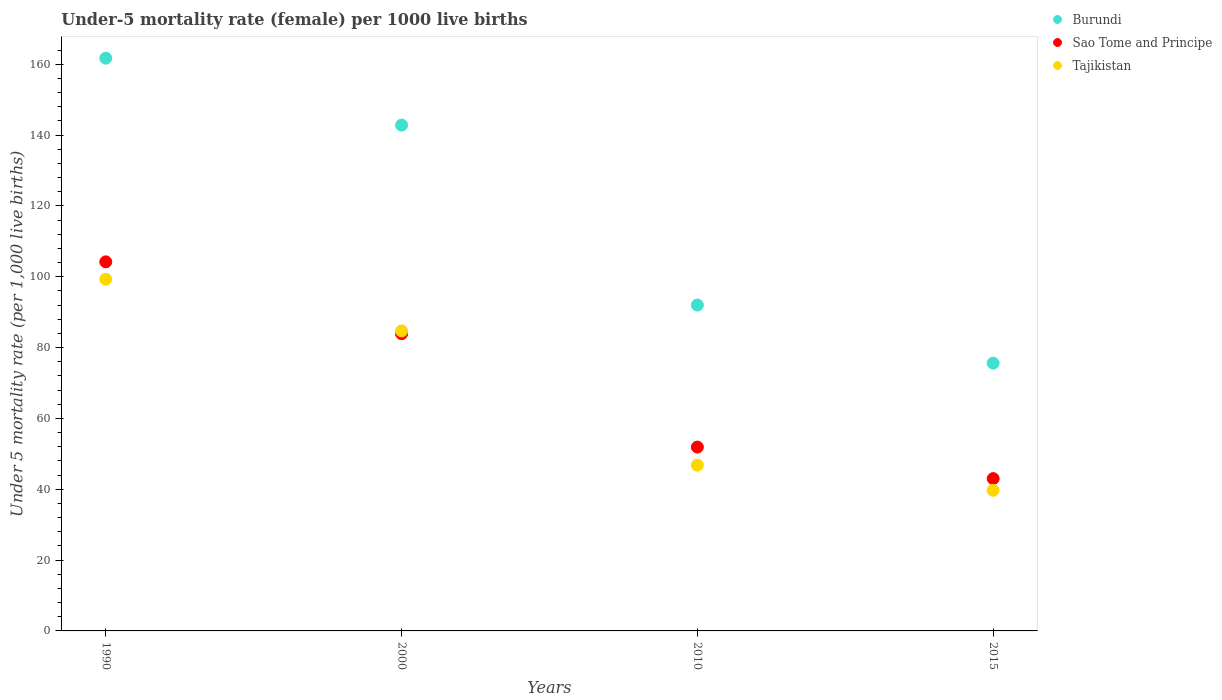How many different coloured dotlines are there?
Your response must be concise. 3. Is the number of dotlines equal to the number of legend labels?
Your answer should be very brief. Yes. What is the under-five mortality rate in Sao Tome and Principe in 1990?
Offer a very short reply. 104.2. Across all years, what is the maximum under-five mortality rate in Burundi?
Make the answer very short. 161.7. Across all years, what is the minimum under-five mortality rate in Tajikistan?
Your answer should be compact. 39.7. In which year was the under-five mortality rate in Burundi minimum?
Keep it short and to the point. 2015. What is the total under-five mortality rate in Burundi in the graph?
Ensure brevity in your answer.  472.1. What is the difference between the under-five mortality rate in Sao Tome and Principe in 2010 and that in 2015?
Provide a succinct answer. 8.9. What is the difference between the under-five mortality rate in Tajikistan in 1990 and the under-five mortality rate in Sao Tome and Principe in 2000?
Give a very brief answer. 15.4. What is the average under-five mortality rate in Tajikistan per year?
Offer a very short reply. 67.62. In the year 1990, what is the difference between the under-five mortality rate in Sao Tome and Principe and under-five mortality rate in Burundi?
Your answer should be compact. -57.5. In how many years, is the under-five mortality rate in Tajikistan greater than 68?
Your response must be concise. 2. What is the ratio of the under-five mortality rate in Tajikistan in 1990 to that in 2000?
Your response must be concise. 1.17. Is the difference between the under-five mortality rate in Sao Tome and Principe in 1990 and 2010 greater than the difference between the under-five mortality rate in Burundi in 1990 and 2010?
Make the answer very short. No. What is the difference between the highest and the second highest under-five mortality rate in Tajikistan?
Offer a very short reply. 14.6. What is the difference between the highest and the lowest under-five mortality rate in Sao Tome and Principe?
Ensure brevity in your answer.  61.2. Is it the case that in every year, the sum of the under-five mortality rate in Tajikistan and under-five mortality rate in Sao Tome and Principe  is greater than the under-five mortality rate in Burundi?
Make the answer very short. Yes. Is the under-five mortality rate in Burundi strictly greater than the under-five mortality rate in Sao Tome and Principe over the years?
Your answer should be compact. Yes. What is the difference between two consecutive major ticks on the Y-axis?
Keep it short and to the point. 20. Are the values on the major ticks of Y-axis written in scientific E-notation?
Your response must be concise. No. Does the graph contain grids?
Provide a succinct answer. No. What is the title of the graph?
Your answer should be compact. Under-5 mortality rate (female) per 1000 live births. Does "Iraq" appear as one of the legend labels in the graph?
Make the answer very short. No. What is the label or title of the X-axis?
Give a very brief answer. Years. What is the label or title of the Y-axis?
Your answer should be very brief. Under 5 mortality rate (per 1,0 live births). What is the Under 5 mortality rate (per 1,000 live births) of Burundi in 1990?
Provide a short and direct response. 161.7. What is the Under 5 mortality rate (per 1,000 live births) in Sao Tome and Principe in 1990?
Make the answer very short. 104.2. What is the Under 5 mortality rate (per 1,000 live births) of Tajikistan in 1990?
Offer a very short reply. 99.3. What is the Under 5 mortality rate (per 1,000 live births) in Burundi in 2000?
Provide a succinct answer. 142.8. What is the Under 5 mortality rate (per 1,000 live births) in Sao Tome and Principe in 2000?
Offer a terse response. 83.9. What is the Under 5 mortality rate (per 1,000 live births) in Tajikistan in 2000?
Keep it short and to the point. 84.7. What is the Under 5 mortality rate (per 1,000 live births) of Burundi in 2010?
Keep it short and to the point. 92. What is the Under 5 mortality rate (per 1,000 live births) in Sao Tome and Principe in 2010?
Offer a very short reply. 51.9. What is the Under 5 mortality rate (per 1,000 live births) of Tajikistan in 2010?
Your answer should be compact. 46.8. What is the Under 5 mortality rate (per 1,000 live births) of Burundi in 2015?
Give a very brief answer. 75.6. What is the Under 5 mortality rate (per 1,000 live births) of Tajikistan in 2015?
Make the answer very short. 39.7. Across all years, what is the maximum Under 5 mortality rate (per 1,000 live births) in Burundi?
Offer a terse response. 161.7. Across all years, what is the maximum Under 5 mortality rate (per 1,000 live births) of Sao Tome and Principe?
Give a very brief answer. 104.2. Across all years, what is the maximum Under 5 mortality rate (per 1,000 live births) in Tajikistan?
Give a very brief answer. 99.3. Across all years, what is the minimum Under 5 mortality rate (per 1,000 live births) in Burundi?
Provide a succinct answer. 75.6. Across all years, what is the minimum Under 5 mortality rate (per 1,000 live births) of Sao Tome and Principe?
Ensure brevity in your answer.  43. Across all years, what is the minimum Under 5 mortality rate (per 1,000 live births) in Tajikistan?
Ensure brevity in your answer.  39.7. What is the total Under 5 mortality rate (per 1,000 live births) of Burundi in the graph?
Your response must be concise. 472.1. What is the total Under 5 mortality rate (per 1,000 live births) of Sao Tome and Principe in the graph?
Give a very brief answer. 283. What is the total Under 5 mortality rate (per 1,000 live births) in Tajikistan in the graph?
Your response must be concise. 270.5. What is the difference between the Under 5 mortality rate (per 1,000 live births) of Burundi in 1990 and that in 2000?
Your response must be concise. 18.9. What is the difference between the Under 5 mortality rate (per 1,000 live births) of Sao Tome and Principe in 1990 and that in 2000?
Make the answer very short. 20.3. What is the difference between the Under 5 mortality rate (per 1,000 live births) in Tajikistan in 1990 and that in 2000?
Your response must be concise. 14.6. What is the difference between the Under 5 mortality rate (per 1,000 live births) of Burundi in 1990 and that in 2010?
Your answer should be very brief. 69.7. What is the difference between the Under 5 mortality rate (per 1,000 live births) of Sao Tome and Principe in 1990 and that in 2010?
Your answer should be compact. 52.3. What is the difference between the Under 5 mortality rate (per 1,000 live births) of Tajikistan in 1990 and that in 2010?
Give a very brief answer. 52.5. What is the difference between the Under 5 mortality rate (per 1,000 live births) of Burundi in 1990 and that in 2015?
Ensure brevity in your answer.  86.1. What is the difference between the Under 5 mortality rate (per 1,000 live births) in Sao Tome and Principe in 1990 and that in 2015?
Your answer should be very brief. 61.2. What is the difference between the Under 5 mortality rate (per 1,000 live births) of Tajikistan in 1990 and that in 2015?
Your response must be concise. 59.6. What is the difference between the Under 5 mortality rate (per 1,000 live births) of Burundi in 2000 and that in 2010?
Your answer should be compact. 50.8. What is the difference between the Under 5 mortality rate (per 1,000 live births) of Sao Tome and Principe in 2000 and that in 2010?
Keep it short and to the point. 32. What is the difference between the Under 5 mortality rate (per 1,000 live births) in Tajikistan in 2000 and that in 2010?
Offer a very short reply. 37.9. What is the difference between the Under 5 mortality rate (per 1,000 live births) of Burundi in 2000 and that in 2015?
Offer a very short reply. 67.2. What is the difference between the Under 5 mortality rate (per 1,000 live births) in Sao Tome and Principe in 2000 and that in 2015?
Your response must be concise. 40.9. What is the difference between the Under 5 mortality rate (per 1,000 live births) of Tajikistan in 2000 and that in 2015?
Offer a terse response. 45. What is the difference between the Under 5 mortality rate (per 1,000 live births) in Burundi in 2010 and that in 2015?
Offer a very short reply. 16.4. What is the difference between the Under 5 mortality rate (per 1,000 live births) of Sao Tome and Principe in 2010 and that in 2015?
Provide a short and direct response. 8.9. What is the difference between the Under 5 mortality rate (per 1,000 live births) in Tajikistan in 2010 and that in 2015?
Ensure brevity in your answer.  7.1. What is the difference between the Under 5 mortality rate (per 1,000 live births) in Burundi in 1990 and the Under 5 mortality rate (per 1,000 live births) in Sao Tome and Principe in 2000?
Your response must be concise. 77.8. What is the difference between the Under 5 mortality rate (per 1,000 live births) of Burundi in 1990 and the Under 5 mortality rate (per 1,000 live births) of Sao Tome and Principe in 2010?
Offer a very short reply. 109.8. What is the difference between the Under 5 mortality rate (per 1,000 live births) in Burundi in 1990 and the Under 5 mortality rate (per 1,000 live births) in Tajikistan in 2010?
Your response must be concise. 114.9. What is the difference between the Under 5 mortality rate (per 1,000 live births) of Sao Tome and Principe in 1990 and the Under 5 mortality rate (per 1,000 live births) of Tajikistan in 2010?
Make the answer very short. 57.4. What is the difference between the Under 5 mortality rate (per 1,000 live births) of Burundi in 1990 and the Under 5 mortality rate (per 1,000 live births) of Sao Tome and Principe in 2015?
Keep it short and to the point. 118.7. What is the difference between the Under 5 mortality rate (per 1,000 live births) in Burundi in 1990 and the Under 5 mortality rate (per 1,000 live births) in Tajikistan in 2015?
Your answer should be very brief. 122. What is the difference between the Under 5 mortality rate (per 1,000 live births) of Sao Tome and Principe in 1990 and the Under 5 mortality rate (per 1,000 live births) of Tajikistan in 2015?
Provide a short and direct response. 64.5. What is the difference between the Under 5 mortality rate (per 1,000 live births) of Burundi in 2000 and the Under 5 mortality rate (per 1,000 live births) of Sao Tome and Principe in 2010?
Your response must be concise. 90.9. What is the difference between the Under 5 mortality rate (per 1,000 live births) of Burundi in 2000 and the Under 5 mortality rate (per 1,000 live births) of Tajikistan in 2010?
Offer a very short reply. 96. What is the difference between the Under 5 mortality rate (per 1,000 live births) in Sao Tome and Principe in 2000 and the Under 5 mortality rate (per 1,000 live births) in Tajikistan in 2010?
Your response must be concise. 37.1. What is the difference between the Under 5 mortality rate (per 1,000 live births) in Burundi in 2000 and the Under 5 mortality rate (per 1,000 live births) in Sao Tome and Principe in 2015?
Provide a succinct answer. 99.8. What is the difference between the Under 5 mortality rate (per 1,000 live births) in Burundi in 2000 and the Under 5 mortality rate (per 1,000 live births) in Tajikistan in 2015?
Provide a succinct answer. 103.1. What is the difference between the Under 5 mortality rate (per 1,000 live births) in Sao Tome and Principe in 2000 and the Under 5 mortality rate (per 1,000 live births) in Tajikistan in 2015?
Make the answer very short. 44.2. What is the difference between the Under 5 mortality rate (per 1,000 live births) in Burundi in 2010 and the Under 5 mortality rate (per 1,000 live births) in Sao Tome and Principe in 2015?
Your response must be concise. 49. What is the difference between the Under 5 mortality rate (per 1,000 live births) of Burundi in 2010 and the Under 5 mortality rate (per 1,000 live births) of Tajikistan in 2015?
Your answer should be very brief. 52.3. What is the difference between the Under 5 mortality rate (per 1,000 live births) of Sao Tome and Principe in 2010 and the Under 5 mortality rate (per 1,000 live births) of Tajikistan in 2015?
Offer a terse response. 12.2. What is the average Under 5 mortality rate (per 1,000 live births) of Burundi per year?
Make the answer very short. 118.03. What is the average Under 5 mortality rate (per 1,000 live births) of Sao Tome and Principe per year?
Keep it short and to the point. 70.75. What is the average Under 5 mortality rate (per 1,000 live births) in Tajikistan per year?
Keep it short and to the point. 67.62. In the year 1990, what is the difference between the Under 5 mortality rate (per 1,000 live births) in Burundi and Under 5 mortality rate (per 1,000 live births) in Sao Tome and Principe?
Provide a short and direct response. 57.5. In the year 1990, what is the difference between the Under 5 mortality rate (per 1,000 live births) in Burundi and Under 5 mortality rate (per 1,000 live births) in Tajikistan?
Keep it short and to the point. 62.4. In the year 1990, what is the difference between the Under 5 mortality rate (per 1,000 live births) in Sao Tome and Principe and Under 5 mortality rate (per 1,000 live births) in Tajikistan?
Your answer should be very brief. 4.9. In the year 2000, what is the difference between the Under 5 mortality rate (per 1,000 live births) of Burundi and Under 5 mortality rate (per 1,000 live births) of Sao Tome and Principe?
Your answer should be compact. 58.9. In the year 2000, what is the difference between the Under 5 mortality rate (per 1,000 live births) in Burundi and Under 5 mortality rate (per 1,000 live births) in Tajikistan?
Your answer should be compact. 58.1. In the year 2010, what is the difference between the Under 5 mortality rate (per 1,000 live births) of Burundi and Under 5 mortality rate (per 1,000 live births) of Sao Tome and Principe?
Give a very brief answer. 40.1. In the year 2010, what is the difference between the Under 5 mortality rate (per 1,000 live births) of Burundi and Under 5 mortality rate (per 1,000 live births) of Tajikistan?
Offer a very short reply. 45.2. In the year 2015, what is the difference between the Under 5 mortality rate (per 1,000 live births) in Burundi and Under 5 mortality rate (per 1,000 live births) in Sao Tome and Principe?
Offer a very short reply. 32.6. In the year 2015, what is the difference between the Under 5 mortality rate (per 1,000 live births) in Burundi and Under 5 mortality rate (per 1,000 live births) in Tajikistan?
Offer a very short reply. 35.9. In the year 2015, what is the difference between the Under 5 mortality rate (per 1,000 live births) of Sao Tome and Principe and Under 5 mortality rate (per 1,000 live births) of Tajikistan?
Keep it short and to the point. 3.3. What is the ratio of the Under 5 mortality rate (per 1,000 live births) in Burundi in 1990 to that in 2000?
Ensure brevity in your answer.  1.13. What is the ratio of the Under 5 mortality rate (per 1,000 live births) in Sao Tome and Principe in 1990 to that in 2000?
Your response must be concise. 1.24. What is the ratio of the Under 5 mortality rate (per 1,000 live births) in Tajikistan in 1990 to that in 2000?
Ensure brevity in your answer.  1.17. What is the ratio of the Under 5 mortality rate (per 1,000 live births) in Burundi in 1990 to that in 2010?
Offer a very short reply. 1.76. What is the ratio of the Under 5 mortality rate (per 1,000 live births) in Sao Tome and Principe in 1990 to that in 2010?
Provide a succinct answer. 2.01. What is the ratio of the Under 5 mortality rate (per 1,000 live births) in Tajikistan in 1990 to that in 2010?
Provide a succinct answer. 2.12. What is the ratio of the Under 5 mortality rate (per 1,000 live births) of Burundi in 1990 to that in 2015?
Your answer should be very brief. 2.14. What is the ratio of the Under 5 mortality rate (per 1,000 live births) of Sao Tome and Principe in 1990 to that in 2015?
Keep it short and to the point. 2.42. What is the ratio of the Under 5 mortality rate (per 1,000 live births) of Tajikistan in 1990 to that in 2015?
Your response must be concise. 2.5. What is the ratio of the Under 5 mortality rate (per 1,000 live births) of Burundi in 2000 to that in 2010?
Offer a very short reply. 1.55. What is the ratio of the Under 5 mortality rate (per 1,000 live births) of Sao Tome and Principe in 2000 to that in 2010?
Ensure brevity in your answer.  1.62. What is the ratio of the Under 5 mortality rate (per 1,000 live births) in Tajikistan in 2000 to that in 2010?
Provide a succinct answer. 1.81. What is the ratio of the Under 5 mortality rate (per 1,000 live births) in Burundi in 2000 to that in 2015?
Offer a terse response. 1.89. What is the ratio of the Under 5 mortality rate (per 1,000 live births) of Sao Tome and Principe in 2000 to that in 2015?
Provide a succinct answer. 1.95. What is the ratio of the Under 5 mortality rate (per 1,000 live births) in Tajikistan in 2000 to that in 2015?
Provide a succinct answer. 2.13. What is the ratio of the Under 5 mortality rate (per 1,000 live births) of Burundi in 2010 to that in 2015?
Your answer should be very brief. 1.22. What is the ratio of the Under 5 mortality rate (per 1,000 live births) of Sao Tome and Principe in 2010 to that in 2015?
Your answer should be very brief. 1.21. What is the ratio of the Under 5 mortality rate (per 1,000 live births) in Tajikistan in 2010 to that in 2015?
Ensure brevity in your answer.  1.18. What is the difference between the highest and the second highest Under 5 mortality rate (per 1,000 live births) of Burundi?
Your answer should be very brief. 18.9. What is the difference between the highest and the second highest Under 5 mortality rate (per 1,000 live births) of Sao Tome and Principe?
Give a very brief answer. 20.3. What is the difference between the highest and the lowest Under 5 mortality rate (per 1,000 live births) of Burundi?
Provide a short and direct response. 86.1. What is the difference between the highest and the lowest Under 5 mortality rate (per 1,000 live births) of Sao Tome and Principe?
Offer a very short reply. 61.2. What is the difference between the highest and the lowest Under 5 mortality rate (per 1,000 live births) of Tajikistan?
Your answer should be compact. 59.6. 